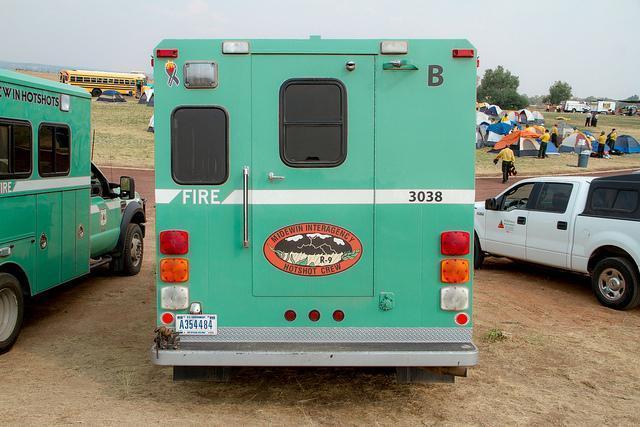How many buses can be seen?
Give a very brief answer. 1. How many trucks are there?
Give a very brief answer. 3. 